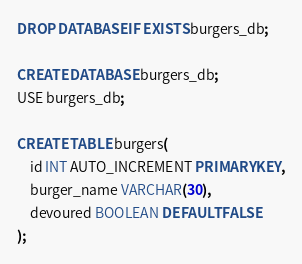<code> <loc_0><loc_0><loc_500><loc_500><_SQL_>DROP DATABASE IF EXISTS burgers_db;

CREATE DATABASE burgers_db;
USE burgers_db;

CREATE TABLE burgers(
    id INT AUTO_INCREMENT PRIMARY KEY,
    burger_name VARCHAR(30),
    devoured BOOLEAN DEFAULT FALSE
);</code> 